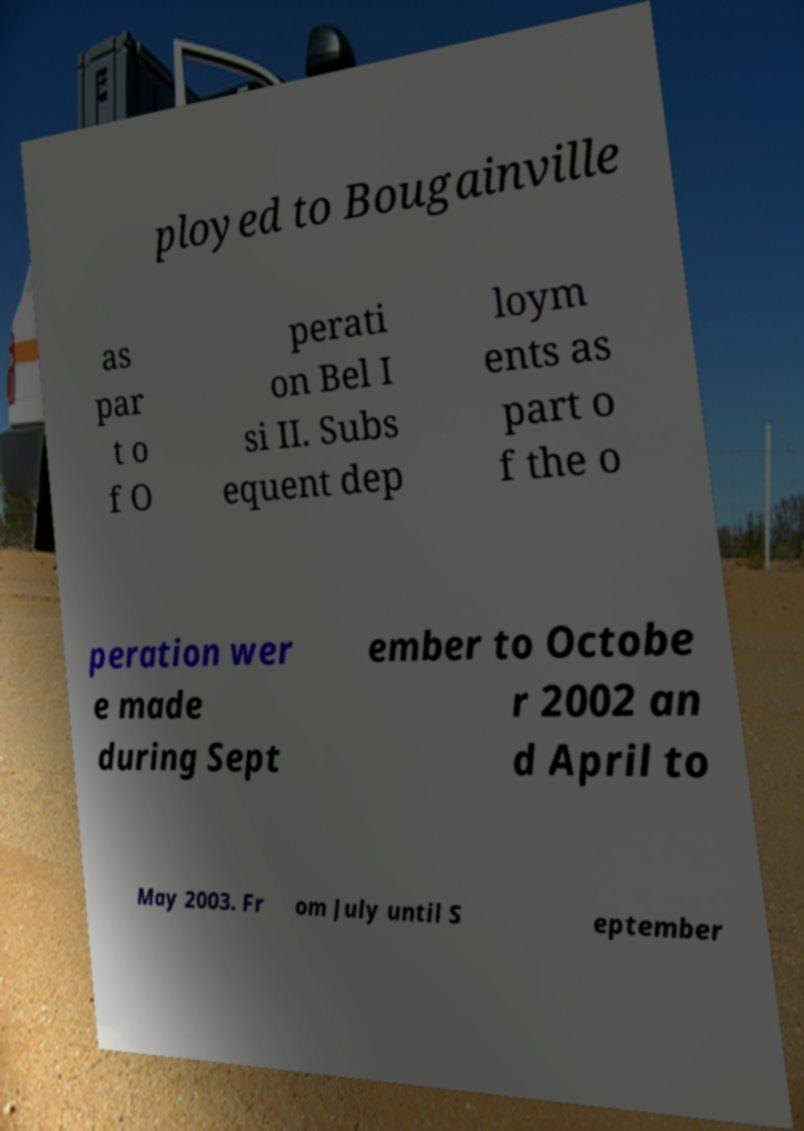Please read and relay the text visible in this image. What does it say? ployed to Bougainville as par t o f O perati on Bel I si II. Subs equent dep loym ents as part o f the o peration wer e made during Sept ember to Octobe r 2002 an d April to May 2003. Fr om July until S eptember 